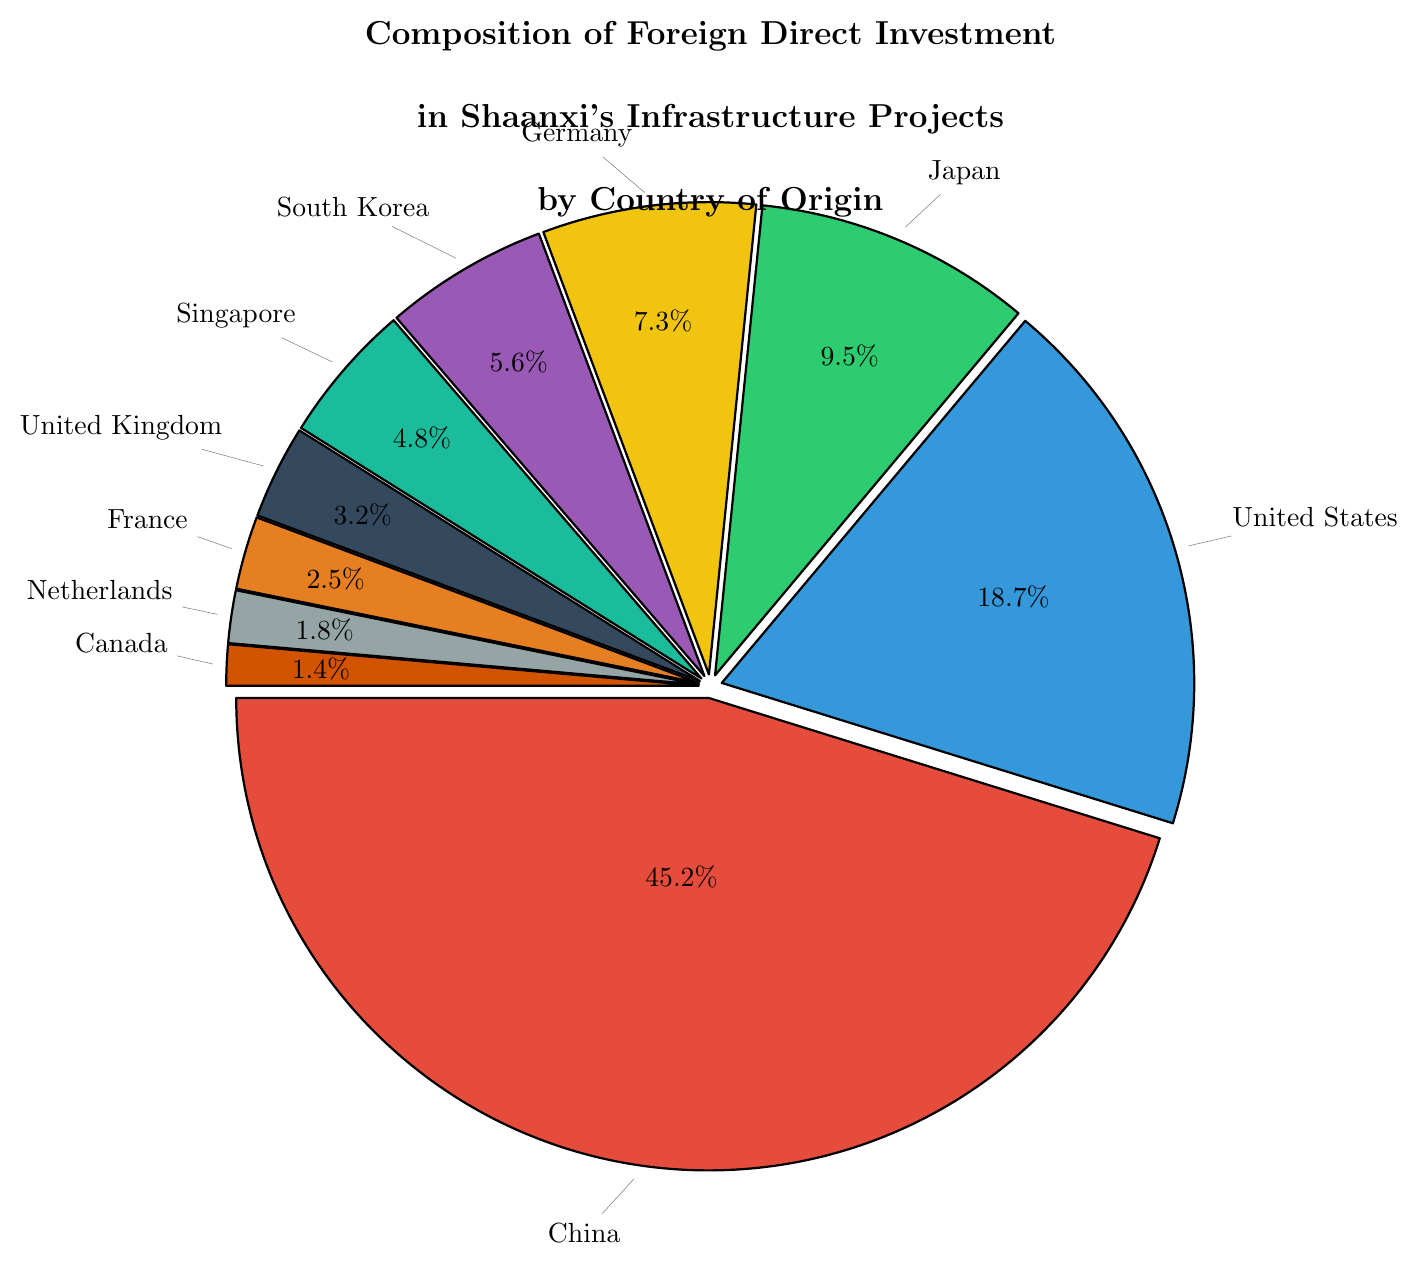What is the sum of the percentages for China, United States, and Japan? The sums of the percentages are calculated as follows: 45.2 (China) + 18.7 (United States) + 9.5 (Japan) = 73.4.
Answer: 73.4 Which country has the lowest percentage of foreign direct investment in Shaanxi's infrastructure projects? Looking at the percentages, Canada has the lowest percentage with 1.4%.
Answer: Canada How much higher is the percentage of foreign direct investment from China compared to Germany? The percentage from China is 45.2%, and from Germany is 7.3%. The difference is 45.2 - 7.3 = 37.9.
Answer: 37.9 What is the average percentage of foreign direct investment from the top five contributing countries? The top five countries and their percentages are China (45.2), United States (18.7), Japan (9.5), Germany (7.3), and South Korea (5.6). The average is calculated as (45.2 + 18.7 + 9.5 + 7.3 + 5.6) / 5 = 17.26%.
Answer: 17.26% Which two countries have similar percentages of foreign direct investment? Comparing the percentages, South Korea has 5.6% and Singapore has 4.8%, which are relatively close.
Answer: South Korea and Singapore What percentage of foreign direct investment is from countries with less than 5% investment each? Countries less than 5%: Singapore (4.8), United Kingdom (3.2), France (2.5), Netherlands (1.8), Canada (1.4). Total sum: 4.8 + 3.2 + 2.5 + 1.8 + 1.4 = 13.7%.
Answer: 13.7 Which country contributes more, France or the United Kingdom and by how much? France contributes 2.5% and the United Kingdom contributes 3.2%. The contribution difference is 3.2 - 2.5 = 0.7%.
Answer: United Kingdom by 0.7 If you combine the foreign direct investments from Germany and South Korea, how does this new total compare to the investment from Japan? Germany (7.3) + South Korea (5.6) = 12.9. Japan contributes 9.5%. The combined total of Germany and South Korea is higher.
Answer: Higher by 3.4 What color represents the slice for the United States? By examining the pie chart, the United States is represented by the color blue.
Answer: Blue What is the ratio of foreign direct investment from China to Japan? The investment from China is 45.2 and from Japan is 9.5. The ratio is calculated as 45.2 / 9.5 ≈ 4.75.
Answer: 4.75 